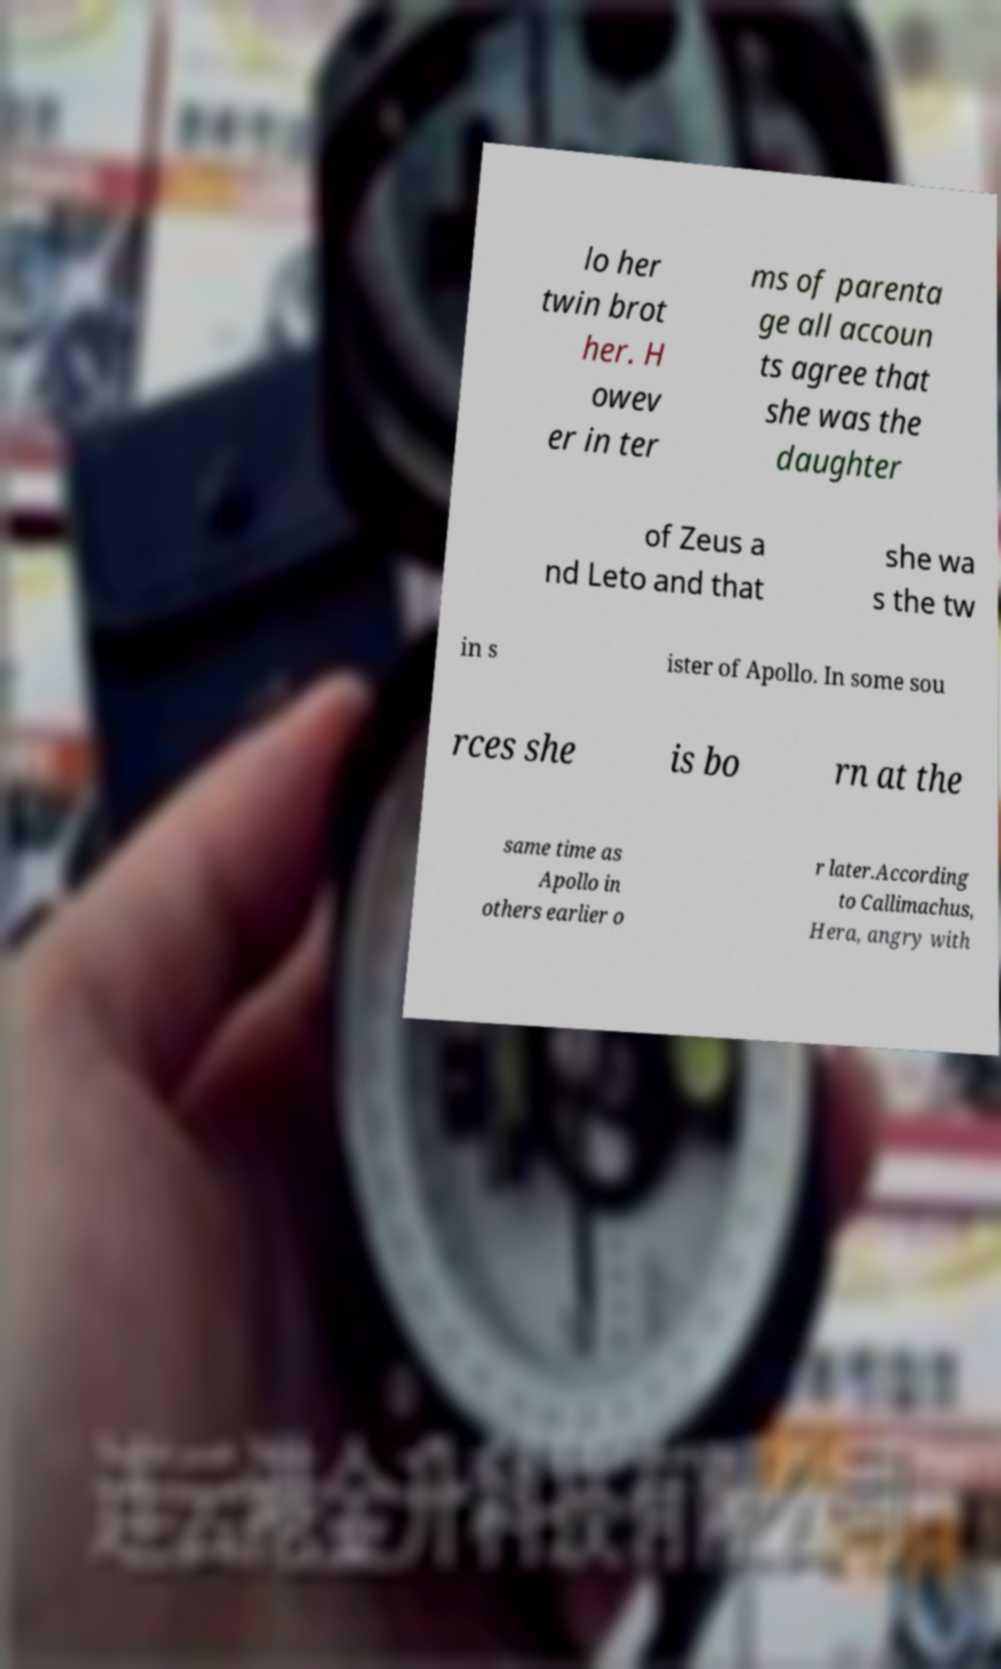I need the written content from this picture converted into text. Can you do that? lo her twin brot her. H owev er in ter ms of parenta ge all accoun ts agree that she was the daughter of Zeus a nd Leto and that she wa s the tw in s ister of Apollo. In some sou rces she is bo rn at the same time as Apollo in others earlier o r later.According to Callimachus, Hera, angry with 